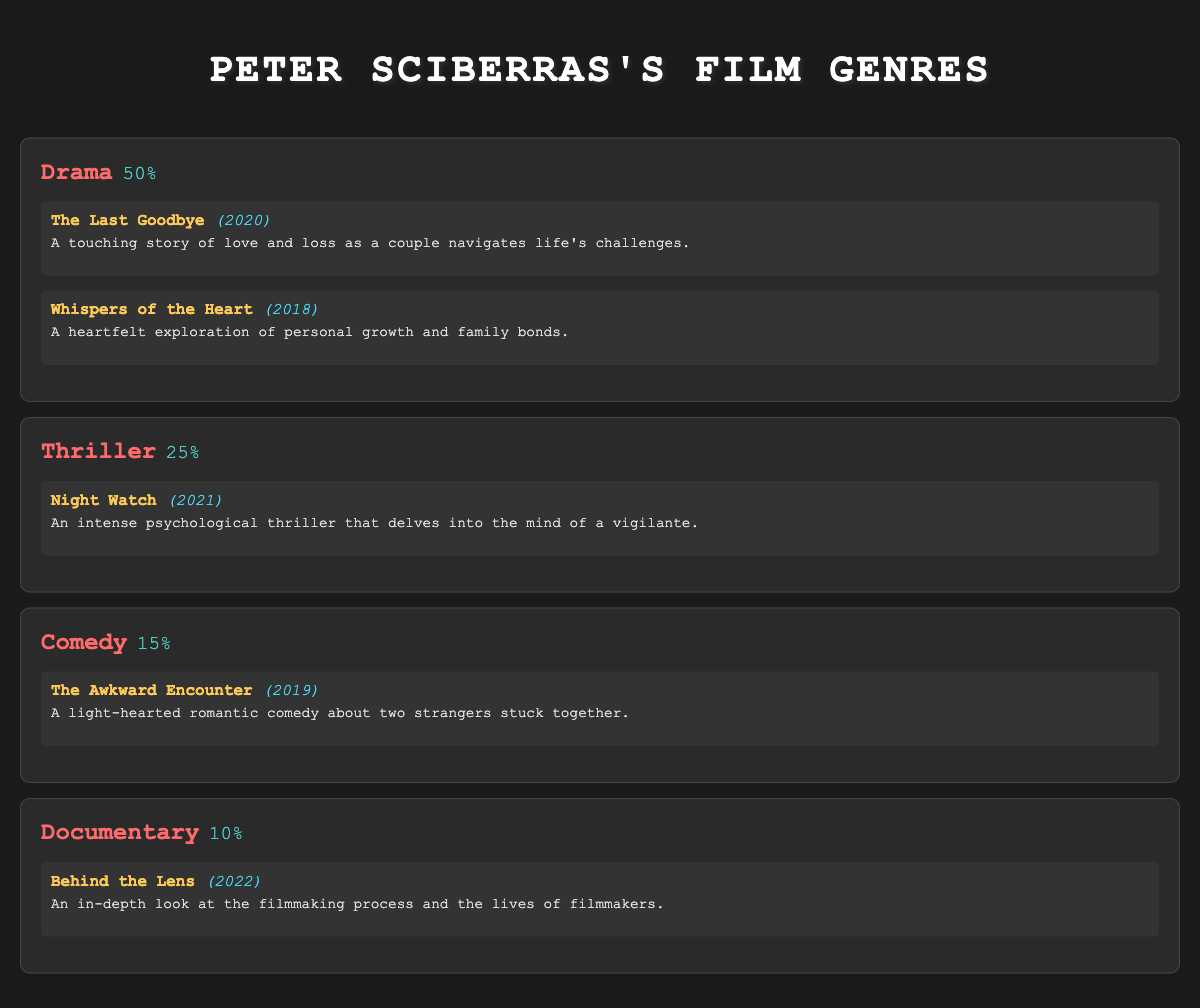What percentage of Peter Sciberras's works are classified as Drama? According to the table, Drama has a percentage listed as 50%.
Answer: 50% Which film released in 2021 is categorized under Thriller? The table shows that "Night Watch" is the only film listed under Thriller, with a release year of 2021.
Answer: Night Watch How many genres have a higher percentage than Comedy? The table displays three genres (Drama and Thriller) that have a higher percentage than Comedy (which is 15%). Drama is 50% and Thriller is 25%.
Answer: 2 What is the total percentage of all genres listed in Peter Sciberras's works? By adding the percentages: 50% (Drama) + 25% (Thriller) + 15% (Comedy) + 10% (Documentary) gives a total of 100%.
Answer: 100% Is "Behind the Lens" a documentary? Based on the table, "Behind the Lens" is categorized under the Documentary genre, confirming that the statement is true.
Answer: Yes Which genre has the least number of titles? The table shows Documentary has only one title, "Behind the Lens," which is the least compared to other genres.
Answer: Documentary What is the average percentage of the genres listed? To find the average, sum the percentages (50 + 25 + 15 + 10 = 100) and divide by the number of genres (4). 100/4 equals 25%.
Answer: 25% In which year was the film "The Awkward Encounter" released? The film "The Awkward Encounter" is listed under Comedy with a release year of 2019 in the table.
Answer: 2019 If you combine the film counts of Drama and Thriller, how many films do you have in total? Counting the films: Drama has 2 titles ("The Last Goodbye" and "Whispers of the Heart") and Thriller has 1 title ("Night Watch"). Adding those gives 2 + 1 = 3 films total.
Answer: 3 